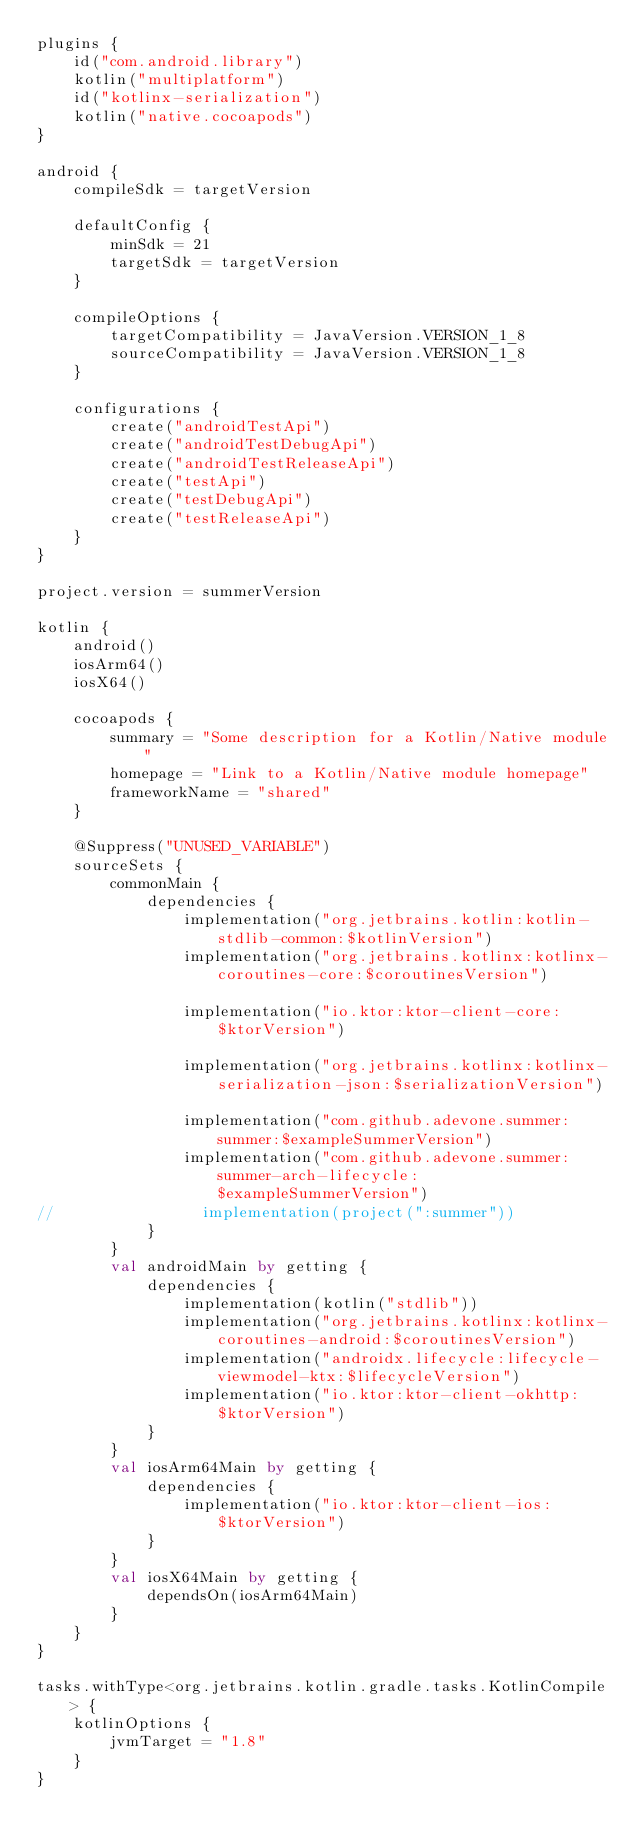<code> <loc_0><loc_0><loc_500><loc_500><_Kotlin_>plugins {
    id("com.android.library")
    kotlin("multiplatform")
    id("kotlinx-serialization")
    kotlin("native.cocoapods")
}

android {
    compileSdk = targetVersion

    defaultConfig {
        minSdk = 21
        targetSdk = targetVersion
    }

    compileOptions {
        targetCompatibility = JavaVersion.VERSION_1_8
        sourceCompatibility = JavaVersion.VERSION_1_8
    }

    configurations {
        create("androidTestApi")
        create("androidTestDebugApi")
        create("androidTestReleaseApi")
        create("testApi")
        create("testDebugApi")
        create("testReleaseApi")
    }
}

project.version = summerVersion

kotlin {
    android()
    iosArm64()
    iosX64()

    cocoapods {
        summary = "Some description for a Kotlin/Native module"
        homepage = "Link to a Kotlin/Native module homepage"
        frameworkName = "shared"
    }

    @Suppress("UNUSED_VARIABLE")
    sourceSets {
        commonMain {
            dependencies {
                implementation("org.jetbrains.kotlin:kotlin-stdlib-common:$kotlinVersion")
                implementation("org.jetbrains.kotlinx:kotlinx-coroutines-core:$coroutinesVersion")

                implementation("io.ktor:ktor-client-core:$ktorVersion")

                implementation("org.jetbrains.kotlinx:kotlinx-serialization-json:$serializationVersion")

                implementation("com.github.adevone.summer:summer:$exampleSummerVersion")
                implementation("com.github.adevone.summer:summer-arch-lifecycle:$exampleSummerVersion")
//                implementation(project(":summer"))
            }
        }
        val androidMain by getting {
            dependencies {
                implementation(kotlin("stdlib"))
                implementation("org.jetbrains.kotlinx:kotlinx-coroutines-android:$coroutinesVersion")
                implementation("androidx.lifecycle:lifecycle-viewmodel-ktx:$lifecycleVersion")
                implementation("io.ktor:ktor-client-okhttp:$ktorVersion")
            }
        }
        val iosArm64Main by getting {
            dependencies {
                implementation("io.ktor:ktor-client-ios:$ktorVersion")
            }
        }
        val iosX64Main by getting {
            dependsOn(iosArm64Main)
        }
    }
}

tasks.withType<org.jetbrains.kotlin.gradle.tasks.KotlinCompile> {
    kotlinOptions {
        jvmTarget = "1.8"
    }
}</code> 